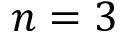<formula> <loc_0><loc_0><loc_500><loc_500>n = 3</formula> 